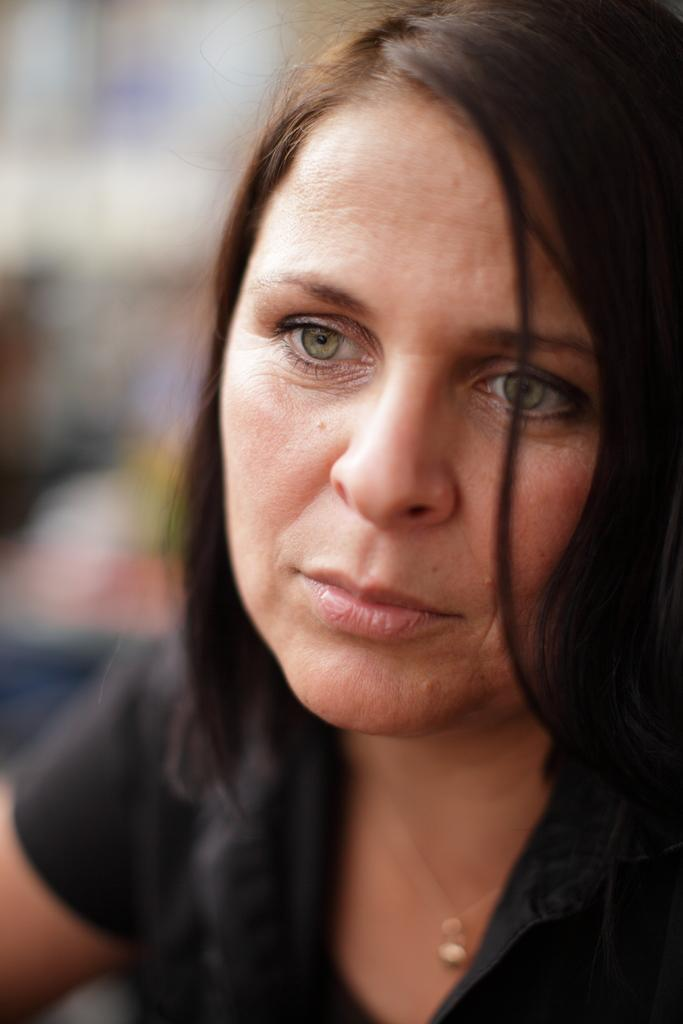What is the main subject of the image? The main subject of the image is a woman. Can you describe the background of the image? The background of the image is blurred. What type of soup is the judge eating in the image? There is no judge or soup present in the image. How many men are visible in the image? There are no men visible in the image; it features a woman. 